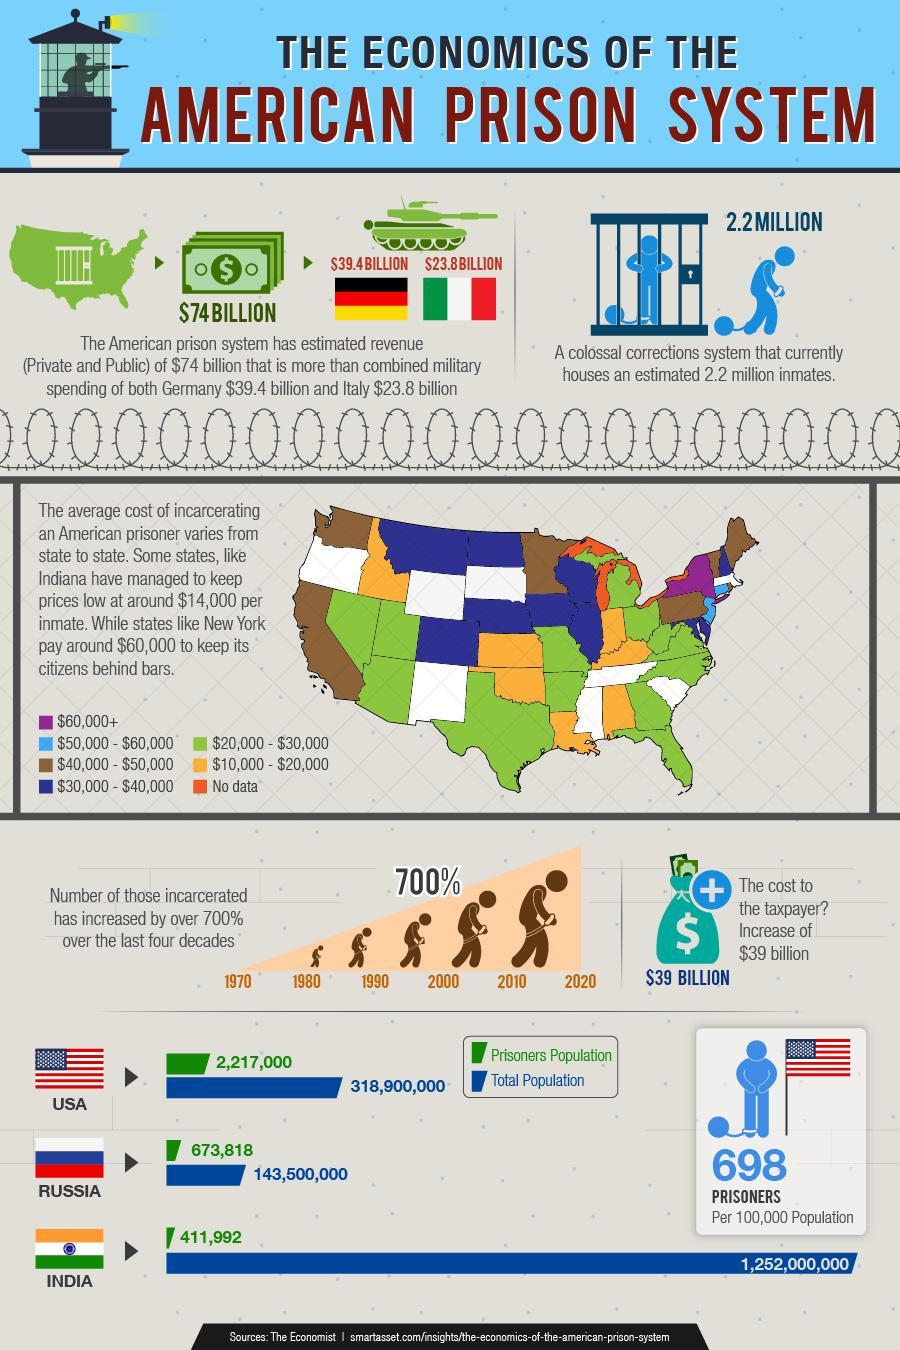what is the difference between military spending of Germany and Italy in billion dollars?
Answer the question with a short phrase. 15.6 military spending of which countries are given in this infographics? Italy, Germany how many states of USA have average cost of incarcerating a prisoner is between $10,000 and $20,000? 7 What is the difference in cost of incarcerating a prisoner of Indiana and New York in dollars? 46000 What is the total population of prisoners in Russia? 673818 Comparison between total population vs prisoners population of which countries are given in this infographics? USA, Russia, India What is the total population of India? 1252000000 What is the total population of Unites states of America? 318,900,000 Comparison between total population vs prisoners population of how many countries are given in this infographics? 3 What is the total population of prisoners in India? 411992 What is the total population of Russia? 143,500,000 What is the total population of prisoners in Unites states of America? 2217000 Which state has higher average cost of incarcerating a prisoner - Indiana or New York? New York What is the total of military spending of Germany and Italy and revenue of American prison system in billion dollars? 137.2 